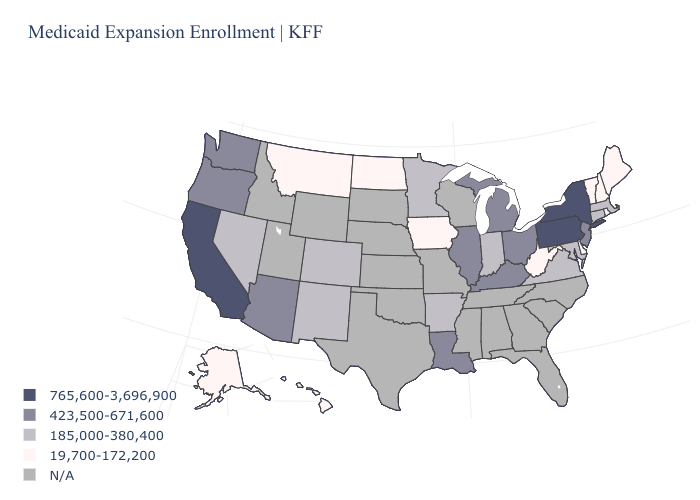Among the states that border Nebraska , which have the highest value?
Concise answer only. Colorado. What is the value of Minnesota?
Concise answer only. 185,000-380,400. Among the states that border Washington , which have the lowest value?
Answer briefly. Oregon. Does Montana have the lowest value in the USA?
Write a very short answer. Yes. Name the states that have a value in the range 19,700-172,200?
Be succinct. Alaska, Delaware, Hawaii, Iowa, Maine, Montana, New Hampshire, North Dakota, Rhode Island, Vermont, West Virginia. Among the states that border North Dakota , which have the lowest value?
Give a very brief answer. Montana. Name the states that have a value in the range 19,700-172,200?
Short answer required. Alaska, Delaware, Hawaii, Iowa, Maine, Montana, New Hampshire, North Dakota, Rhode Island, Vermont, West Virginia. Does Montana have the highest value in the USA?
Quick response, please. No. Does Illinois have the lowest value in the USA?
Short answer required. No. Is the legend a continuous bar?
Be succinct. No. Which states have the lowest value in the Northeast?
Be succinct. Maine, New Hampshire, Rhode Island, Vermont. Does New York have the highest value in the Northeast?
Short answer required. Yes. Which states have the lowest value in the MidWest?
Give a very brief answer. Iowa, North Dakota. Which states have the highest value in the USA?
Write a very short answer. California, New York, Pennsylvania. 